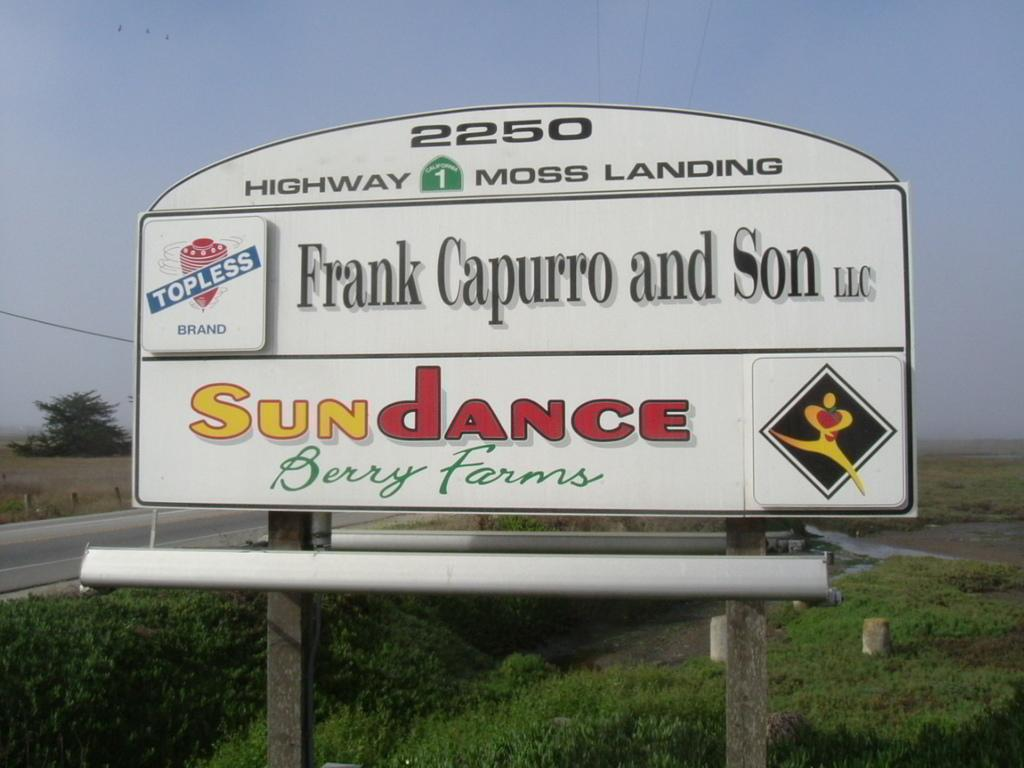<image>
Provide a brief description of the given image. A billboard for Sundance Berry Farms also features Frank Capurro and Son LLC. 